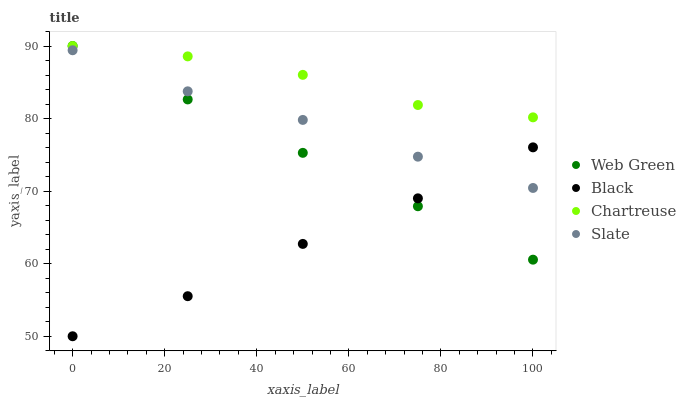Does Black have the minimum area under the curve?
Answer yes or no. Yes. Does Chartreuse have the maximum area under the curve?
Answer yes or no. Yes. Does Slate have the minimum area under the curve?
Answer yes or no. No. Does Slate have the maximum area under the curve?
Answer yes or no. No. Is Web Green the smoothest?
Answer yes or no. Yes. Is Chartreuse the roughest?
Answer yes or no. Yes. Is Black the smoothest?
Answer yes or no. No. Is Black the roughest?
Answer yes or no. No. Does Black have the lowest value?
Answer yes or no. Yes. Does Slate have the lowest value?
Answer yes or no. No. Does Web Green have the highest value?
Answer yes or no. Yes. Does Slate have the highest value?
Answer yes or no. No. Is Black less than Chartreuse?
Answer yes or no. Yes. Is Chartreuse greater than Black?
Answer yes or no. Yes. Does Web Green intersect Black?
Answer yes or no. Yes. Is Web Green less than Black?
Answer yes or no. No. Is Web Green greater than Black?
Answer yes or no. No. Does Black intersect Chartreuse?
Answer yes or no. No. 